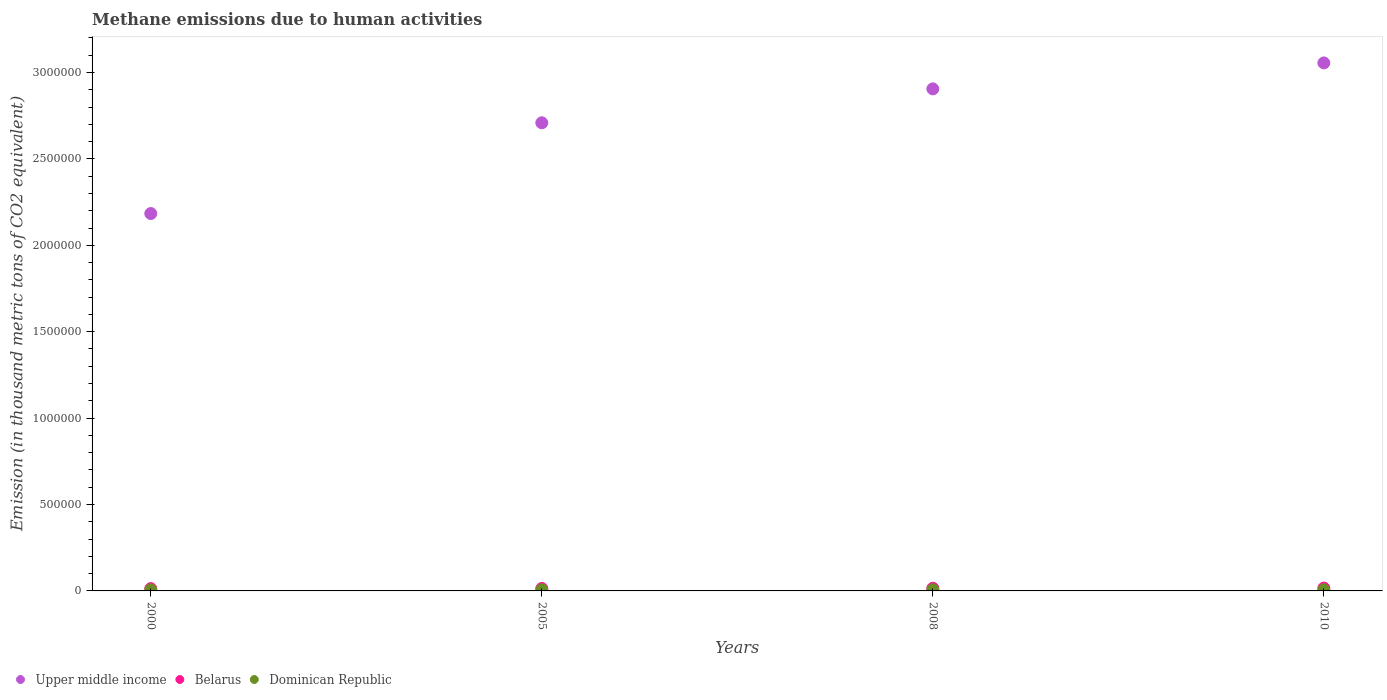How many different coloured dotlines are there?
Offer a terse response. 3. Is the number of dotlines equal to the number of legend labels?
Offer a terse response. Yes. What is the amount of methane emitted in Upper middle income in 2008?
Give a very brief answer. 2.91e+06. Across all years, what is the maximum amount of methane emitted in Upper middle income?
Make the answer very short. 3.06e+06. Across all years, what is the minimum amount of methane emitted in Dominican Republic?
Ensure brevity in your answer.  6238.7. In which year was the amount of methane emitted in Belarus maximum?
Offer a very short reply. 2010. What is the total amount of methane emitted in Belarus in the graph?
Ensure brevity in your answer.  5.92e+04. What is the difference between the amount of methane emitted in Dominican Republic in 2000 and that in 2010?
Your answer should be very brief. -490.4. What is the difference between the amount of methane emitted in Upper middle income in 2005 and the amount of methane emitted in Dominican Republic in 2008?
Your answer should be very brief. 2.70e+06. What is the average amount of methane emitted in Belarus per year?
Offer a very short reply. 1.48e+04. In the year 2000, what is the difference between the amount of methane emitted in Upper middle income and amount of methane emitted in Dominican Republic?
Offer a terse response. 2.18e+06. What is the ratio of the amount of methane emitted in Upper middle income in 2000 to that in 2005?
Provide a succinct answer. 0.81. What is the difference between the highest and the lowest amount of methane emitted in Upper middle income?
Provide a short and direct response. 8.72e+05. In how many years, is the amount of methane emitted in Belarus greater than the average amount of methane emitted in Belarus taken over all years?
Provide a succinct answer. 2. Is the amount of methane emitted in Upper middle income strictly less than the amount of methane emitted in Dominican Republic over the years?
Your response must be concise. No. How many years are there in the graph?
Your response must be concise. 4. What is the difference between two consecutive major ticks on the Y-axis?
Your response must be concise. 5.00e+05. Does the graph contain any zero values?
Keep it short and to the point. No. Does the graph contain grids?
Offer a very short reply. No. How are the legend labels stacked?
Give a very brief answer. Horizontal. What is the title of the graph?
Ensure brevity in your answer.  Methane emissions due to human activities. What is the label or title of the X-axis?
Give a very brief answer. Years. What is the label or title of the Y-axis?
Your answer should be very brief. Emission (in thousand metric tons of CO2 equivalent). What is the Emission (in thousand metric tons of CO2 equivalent) in Upper middle income in 2000?
Your answer should be very brief. 2.18e+06. What is the Emission (in thousand metric tons of CO2 equivalent) in Belarus in 2000?
Your response must be concise. 1.33e+04. What is the Emission (in thousand metric tons of CO2 equivalent) in Dominican Republic in 2000?
Provide a succinct answer. 6238.7. What is the Emission (in thousand metric tons of CO2 equivalent) in Upper middle income in 2005?
Your answer should be compact. 2.71e+06. What is the Emission (in thousand metric tons of CO2 equivalent) in Belarus in 2005?
Provide a succinct answer. 1.40e+04. What is the Emission (in thousand metric tons of CO2 equivalent) in Dominican Republic in 2005?
Your answer should be compact. 6694.7. What is the Emission (in thousand metric tons of CO2 equivalent) of Upper middle income in 2008?
Your answer should be compact. 2.91e+06. What is the Emission (in thousand metric tons of CO2 equivalent) in Belarus in 2008?
Offer a terse response. 1.53e+04. What is the Emission (in thousand metric tons of CO2 equivalent) in Dominican Republic in 2008?
Make the answer very short. 6733.1. What is the Emission (in thousand metric tons of CO2 equivalent) of Upper middle income in 2010?
Your answer should be very brief. 3.06e+06. What is the Emission (in thousand metric tons of CO2 equivalent) in Belarus in 2010?
Your answer should be compact. 1.64e+04. What is the Emission (in thousand metric tons of CO2 equivalent) in Dominican Republic in 2010?
Your answer should be compact. 6729.1. Across all years, what is the maximum Emission (in thousand metric tons of CO2 equivalent) in Upper middle income?
Offer a terse response. 3.06e+06. Across all years, what is the maximum Emission (in thousand metric tons of CO2 equivalent) of Belarus?
Your answer should be very brief. 1.64e+04. Across all years, what is the maximum Emission (in thousand metric tons of CO2 equivalent) of Dominican Republic?
Make the answer very short. 6733.1. Across all years, what is the minimum Emission (in thousand metric tons of CO2 equivalent) in Upper middle income?
Your response must be concise. 2.18e+06. Across all years, what is the minimum Emission (in thousand metric tons of CO2 equivalent) of Belarus?
Provide a short and direct response. 1.33e+04. Across all years, what is the minimum Emission (in thousand metric tons of CO2 equivalent) of Dominican Republic?
Keep it short and to the point. 6238.7. What is the total Emission (in thousand metric tons of CO2 equivalent) in Upper middle income in the graph?
Give a very brief answer. 1.09e+07. What is the total Emission (in thousand metric tons of CO2 equivalent) in Belarus in the graph?
Your response must be concise. 5.92e+04. What is the total Emission (in thousand metric tons of CO2 equivalent) in Dominican Republic in the graph?
Make the answer very short. 2.64e+04. What is the difference between the Emission (in thousand metric tons of CO2 equivalent) of Upper middle income in 2000 and that in 2005?
Provide a short and direct response. -5.25e+05. What is the difference between the Emission (in thousand metric tons of CO2 equivalent) in Belarus in 2000 and that in 2005?
Provide a short and direct response. -723. What is the difference between the Emission (in thousand metric tons of CO2 equivalent) of Dominican Republic in 2000 and that in 2005?
Your answer should be very brief. -456. What is the difference between the Emission (in thousand metric tons of CO2 equivalent) in Upper middle income in 2000 and that in 2008?
Make the answer very short. -7.21e+05. What is the difference between the Emission (in thousand metric tons of CO2 equivalent) in Belarus in 2000 and that in 2008?
Offer a very short reply. -2020.8. What is the difference between the Emission (in thousand metric tons of CO2 equivalent) in Dominican Republic in 2000 and that in 2008?
Your answer should be compact. -494.4. What is the difference between the Emission (in thousand metric tons of CO2 equivalent) of Upper middle income in 2000 and that in 2010?
Ensure brevity in your answer.  -8.72e+05. What is the difference between the Emission (in thousand metric tons of CO2 equivalent) of Belarus in 2000 and that in 2010?
Keep it short and to the point. -3112.7. What is the difference between the Emission (in thousand metric tons of CO2 equivalent) of Dominican Republic in 2000 and that in 2010?
Provide a succinct answer. -490.4. What is the difference between the Emission (in thousand metric tons of CO2 equivalent) in Upper middle income in 2005 and that in 2008?
Provide a succinct answer. -1.96e+05. What is the difference between the Emission (in thousand metric tons of CO2 equivalent) in Belarus in 2005 and that in 2008?
Your answer should be compact. -1297.8. What is the difference between the Emission (in thousand metric tons of CO2 equivalent) in Dominican Republic in 2005 and that in 2008?
Make the answer very short. -38.4. What is the difference between the Emission (in thousand metric tons of CO2 equivalent) of Upper middle income in 2005 and that in 2010?
Make the answer very short. -3.46e+05. What is the difference between the Emission (in thousand metric tons of CO2 equivalent) in Belarus in 2005 and that in 2010?
Your answer should be compact. -2389.7. What is the difference between the Emission (in thousand metric tons of CO2 equivalent) in Dominican Republic in 2005 and that in 2010?
Provide a short and direct response. -34.4. What is the difference between the Emission (in thousand metric tons of CO2 equivalent) of Upper middle income in 2008 and that in 2010?
Ensure brevity in your answer.  -1.50e+05. What is the difference between the Emission (in thousand metric tons of CO2 equivalent) of Belarus in 2008 and that in 2010?
Your response must be concise. -1091.9. What is the difference between the Emission (in thousand metric tons of CO2 equivalent) of Upper middle income in 2000 and the Emission (in thousand metric tons of CO2 equivalent) of Belarus in 2005?
Ensure brevity in your answer.  2.17e+06. What is the difference between the Emission (in thousand metric tons of CO2 equivalent) of Upper middle income in 2000 and the Emission (in thousand metric tons of CO2 equivalent) of Dominican Republic in 2005?
Provide a succinct answer. 2.18e+06. What is the difference between the Emission (in thousand metric tons of CO2 equivalent) in Belarus in 2000 and the Emission (in thousand metric tons of CO2 equivalent) in Dominican Republic in 2005?
Give a very brief answer. 6628.7. What is the difference between the Emission (in thousand metric tons of CO2 equivalent) of Upper middle income in 2000 and the Emission (in thousand metric tons of CO2 equivalent) of Belarus in 2008?
Offer a terse response. 2.17e+06. What is the difference between the Emission (in thousand metric tons of CO2 equivalent) in Upper middle income in 2000 and the Emission (in thousand metric tons of CO2 equivalent) in Dominican Republic in 2008?
Your answer should be compact. 2.18e+06. What is the difference between the Emission (in thousand metric tons of CO2 equivalent) in Belarus in 2000 and the Emission (in thousand metric tons of CO2 equivalent) in Dominican Republic in 2008?
Provide a succinct answer. 6590.3. What is the difference between the Emission (in thousand metric tons of CO2 equivalent) of Upper middle income in 2000 and the Emission (in thousand metric tons of CO2 equivalent) of Belarus in 2010?
Your answer should be very brief. 2.17e+06. What is the difference between the Emission (in thousand metric tons of CO2 equivalent) of Upper middle income in 2000 and the Emission (in thousand metric tons of CO2 equivalent) of Dominican Republic in 2010?
Offer a very short reply. 2.18e+06. What is the difference between the Emission (in thousand metric tons of CO2 equivalent) of Belarus in 2000 and the Emission (in thousand metric tons of CO2 equivalent) of Dominican Republic in 2010?
Provide a succinct answer. 6594.3. What is the difference between the Emission (in thousand metric tons of CO2 equivalent) in Upper middle income in 2005 and the Emission (in thousand metric tons of CO2 equivalent) in Belarus in 2008?
Offer a very short reply. 2.69e+06. What is the difference between the Emission (in thousand metric tons of CO2 equivalent) of Upper middle income in 2005 and the Emission (in thousand metric tons of CO2 equivalent) of Dominican Republic in 2008?
Your answer should be very brief. 2.70e+06. What is the difference between the Emission (in thousand metric tons of CO2 equivalent) of Belarus in 2005 and the Emission (in thousand metric tons of CO2 equivalent) of Dominican Republic in 2008?
Your answer should be very brief. 7313.3. What is the difference between the Emission (in thousand metric tons of CO2 equivalent) in Upper middle income in 2005 and the Emission (in thousand metric tons of CO2 equivalent) in Belarus in 2010?
Your response must be concise. 2.69e+06. What is the difference between the Emission (in thousand metric tons of CO2 equivalent) in Upper middle income in 2005 and the Emission (in thousand metric tons of CO2 equivalent) in Dominican Republic in 2010?
Provide a short and direct response. 2.70e+06. What is the difference between the Emission (in thousand metric tons of CO2 equivalent) in Belarus in 2005 and the Emission (in thousand metric tons of CO2 equivalent) in Dominican Republic in 2010?
Your answer should be very brief. 7317.3. What is the difference between the Emission (in thousand metric tons of CO2 equivalent) of Upper middle income in 2008 and the Emission (in thousand metric tons of CO2 equivalent) of Belarus in 2010?
Your answer should be compact. 2.89e+06. What is the difference between the Emission (in thousand metric tons of CO2 equivalent) in Upper middle income in 2008 and the Emission (in thousand metric tons of CO2 equivalent) in Dominican Republic in 2010?
Ensure brevity in your answer.  2.90e+06. What is the difference between the Emission (in thousand metric tons of CO2 equivalent) of Belarus in 2008 and the Emission (in thousand metric tons of CO2 equivalent) of Dominican Republic in 2010?
Offer a terse response. 8615.1. What is the average Emission (in thousand metric tons of CO2 equivalent) of Upper middle income per year?
Keep it short and to the point. 2.71e+06. What is the average Emission (in thousand metric tons of CO2 equivalent) in Belarus per year?
Provide a succinct answer. 1.48e+04. What is the average Emission (in thousand metric tons of CO2 equivalent) in Dominican Republic per year?
Your answer should be very brief. 6598.9. In the year 2000, what is the difference between the Emission (in thousand metric tons of CO2 equivalent) of Upper middle income and Emission (in thousand metric tons of CO2 equivalent) of Belarus?
Your answer should be compact. 2.17e+06. In the year 2000, what is the difference between the Emission (in thousand metric tons of CO2 equivalent) of Upper middle income and Emission (in thousand metric tons of CO2 equivalent) of Dominican Republic?
Make the answer very short. 2.18e+06. In the year 2000, what is the difference between the Emission (in thousand metric tons of CO2 equivalent) of Belarus and Emission (in thousand metric tons of CO2 equivalent) of Dominican Republic?
Your answer should be very brief. 7084.7. In the year 2005, what is the difference between the Emission (in thousand metric tons of CO2 equivalent) in Upper middle income and Emission (in thousand metric tons of CO2 equivalent) in Belarus?
Offer a very short reply. 2.69e+06. In the year 2005, what is the difference between the Emission (in thousand metric tons of CO2 equivalent) of Upper middle income and Emission (in thousand metric tons of CO2 equivalent) of Dominican Republic?
Keep it short and to the point. 2.70e+06. In the year 2005, what is the difference between the Emission (in thousand metric tons of CO2 equivalent) in Belarus and Emission (in thousand metric tons of CO2 equivalent) in Dominican Republic?
Your response must be concise. 7351.7. In the year 2008, what is the difference between the Emission (in thousand metric tons of CO2 equivalent) in Upper middle income and Emission (in thousand metric tons of CO2 equivalent) in Belarus?
Ensure brevity in your answer.  2.89e+06. In the year 2008, what is the difference between the Emission (in thousand metric tons of CO2 equivalent) of Upper middle income and Emission (in thousand metric tons of CO2 equivalent) of Dominican Republic?
Your response must be concise. 2.90e+06. In the year 2008, what is the difference between the Emission (in thousand metric tons of CO2 equivalent) of Belarus and Emission (in thousand metric tons of CO2 equivalent) of Dominican Republic?
Offer a terse response. 8611.1. In the year 2010, what is the difference between the Emission (in thousand metric tons of CO2 equivalent) of Upper middle income and Emission (in thousand metric tons of CO2 equivalent) of Belarus?
Give a very brief answer. 3.04e+06. In the year 2010, what is the difference between the Emission (in thousand metric tons of CO2 equivalent) of Upper middle income and Emission (in thousand metric tons of CO2 equivalent) of Dominican Republic?
Your answer should be compact. 3.05e+06. In the year 2010, what is the difference between the Emission (in thousand metric tons of CO2 equivalent) in Belarus and Emission (in thousand metric tons of CO2 equivalent) in Dominican Republic?
Make the answer very short. 9707. What is the ratio of the Emission (in thousand metric tons of CO2 equivalent) of Upper middle income in 2000 to that in 2005?
Make the answer very short. 0.81. What is the ratio of the Emission (in thousand metric tons of CO2 equivalent) in Belarus in 2000 to that in 2005?
Offer a terse response. 0.95. What is the ratio of the Emission (in thousand metric tons of CO2 equivalent) in Dominican Republic in 2000 to that in 2005?
Provide a succinct answer. 0.93. What is the ratio of the Emission (in thousand metric tons of CO2 equivalent) in Upper middle income in 2000 to that in 2008?
Provide a short and direct response. 0.75. What is the ratio of the Emission (in thousand metric tons of CO2 equivalent) in Belarus in 2000 to that in 2008?
Offer a very short reply. 0.87. What is the ratio of the Emission (in thousand metric tons of CO2 equivalent) in Dominican Republic in 2000 to that in 2008?
Your answer should be compact. 0.93. What is the ratio of the Emission (in thousand metric tons of CO2 equivalent) of Upper middle income in 2000 to that in 2010?
Give a very brief answer. 0.71. What is the ratio of the Emission (in thousand metric tons of CO2 equivalent) in Belarus in 2000 to that in 2010?
Keep it short and to the point. 0.81. What is the ratio of the Emission (in thousand metric tons of CO2 equivalent) in Dominican Republic in 2000 to that in 2010?
Your answer should be compact. 0.93. What is the ratio of the Emission (in thousand metric tons of CO2 equivalent) in Upper middle income in 2005 to that in 2008?
Your answer should be very brief. 0.93. What is the ratio of the Emission (in thousand metric tons of CO2 equivalent) of Belarus in 2005 to that in 2008?
Provide a short and direct response. 0.92. What is the ratio of the Emission (in thousand metric tons of CO2 equivalent) of Upper middle income in 2005 to that in 2010?
Ensure brevity in your answer.  0.89. What is the ratio of the Emission (in thousand metric tons of CO2 equivalent) in Belarus in 2005 to that in 2010?
Keep it short and to the point. 0.85. What is the ratio of the Emission (in thousand metric tons of CO2 equivalent) of Dominican Republic in 2005 to that in 2010?
Your answer should be very brief. 0.99. What is the ratio of the Emission (in thousand metric tons of CO2 equivalent) in Upper middle income in 2008 to that in 2010?
Make the answer very short. 0.95. What is the ratio of the Emission (in thousand metric tons of CO2 equivalent) in Belarus in 2008 to that in 2010?
Keep it short and to the point. 0.93. What is the ratio of the Emission (in thousand metric tons of CO2 equivalent) of Dominican Republic in 2008 to that in 2010?
Keep it short and to the point. 1. What is the difference between the highest and the second highest Emission (in thousand metric tons of CO2 equivalent) in Upper middle income?
Your answer should be very brief. 1.50e+05. What is the difference between the highest and the second highest Emission (in thousand metric tons of CO2 equivalent) of Belarus?
Offer a terse response. 1091.9. What is the difference between the highest and the second highest Emission (in thousand metric tons of CO2 equivalent) of Dominican Republic?
Provide a short and direct response. 4. What is the difference between the highest and the lowest Emission (in thousand metric tons of CO2 equivalent) of Upper middle income?
Make the answer very short. 8.72e+05. What is the difference between the highest and the lowest Emission (in thousand metric tons of CO2 equivalent) of Belarus?
Ensure brevity in your answer.  3112.7. What is the difference between the highest and the lowest Emission (in thousand metric tons of CO2 equivalent) of Dominican Republic?
Provide a short and direct response. 494.4. 